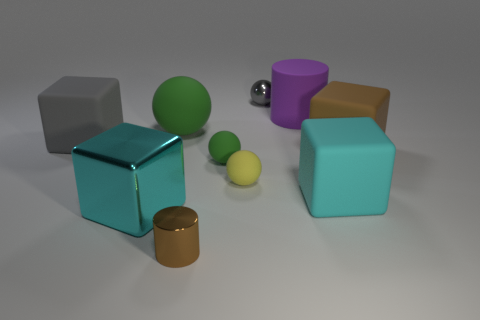Which objects in the image could potentially interact with each other based on their positions? Observing their positions, the matte grey and teal cubes are close enough that they could easily be stacked or arranged side by side. The small yellow spheres are also positioned near each other, implying they could be grouped or moved together. Finally, the shiny green sphere is in close proximity to the cylindrical gold-colored object, suggesting they might be rolled or placed one on top of the other for interaction. 